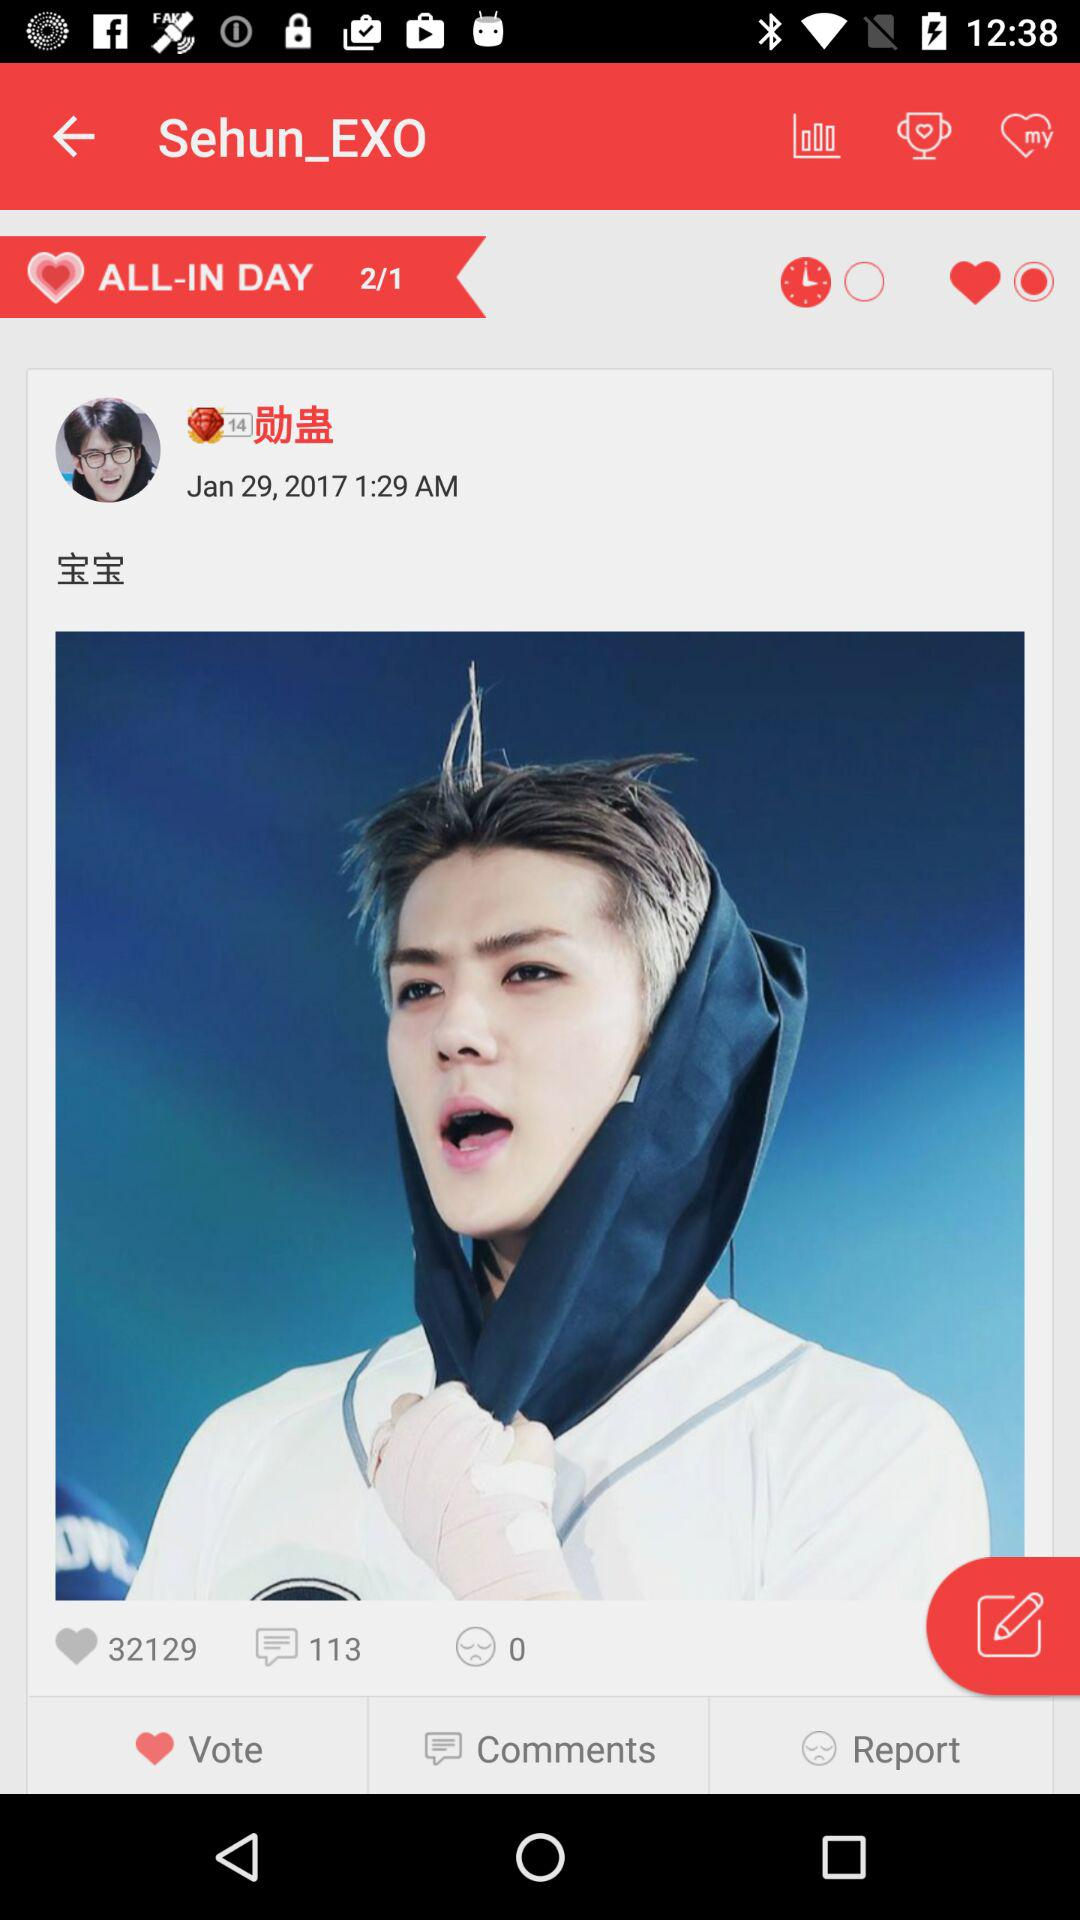Which tab is currently selected?
When the provided information is insufficient, respond with <no answer>. <no answer> 